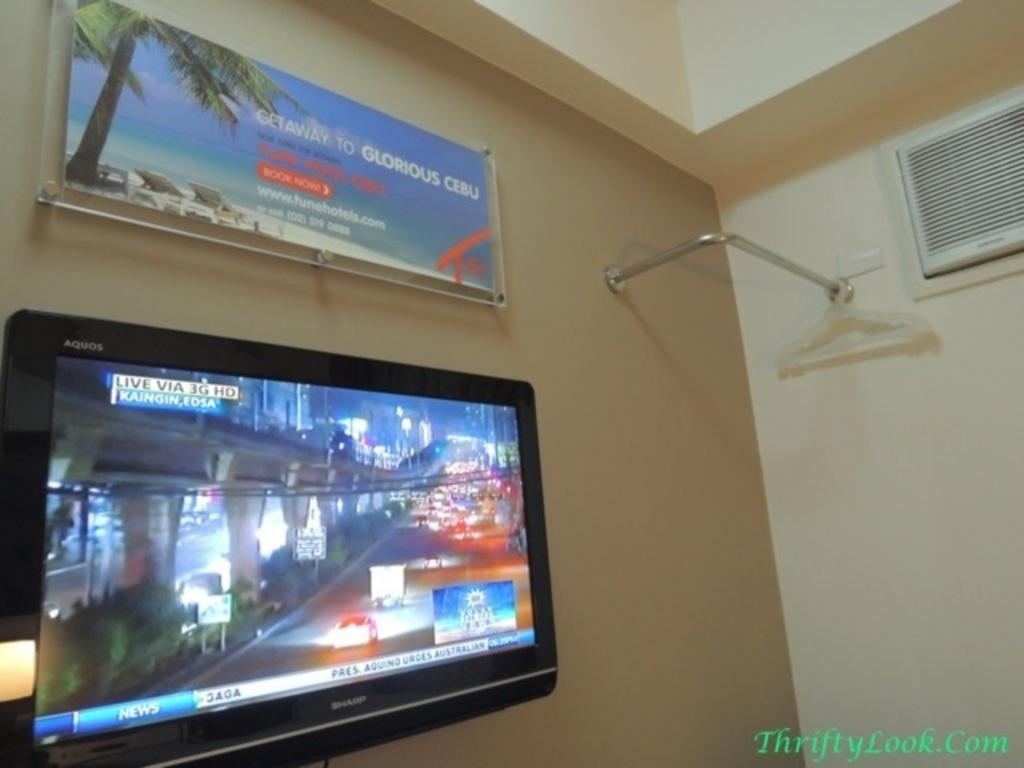Provide a one-sentence caption for the provided image. A poster with the text 'Gateway to Glorious Cebu' hangs on the wall. 